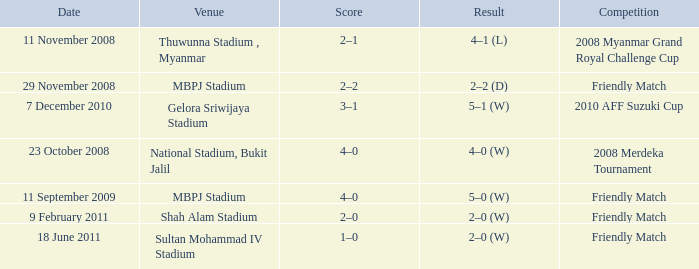Write the full table. {'header': ['Date', 'Venue', 'Score', 'Result', 'Competition'], 'rows': [['11 November 2008', 'Thuwunna Stadium , Myanmar', '2–1', '4–1 (L)', '2008 Myanmar Grand Royal Challenge Cup'], ['29 November 2008', 'MBPJ Stadium', '2–2', '2–2 (D)', 'Friendly Match'], ['7 December 2010', 'Gelora Sriwijaya Stadium', '3–1', '5–1 (W)', '2010 AFF Suzuki Cup'], ['23 October 2008', 'National Stadium, Bukit Jalil', '4–0', '4–0 (W)', '2008 Merdeka Tournament'], ['11 September 2009', 'MBPJ Stadium', '4–0', '5–0 (W)', 'Friendly Match'], ['9 February 2011', 'Shah Alam Stadium', '2–0', '2–0 (W)', 'Friendly Match'], ['18 June 2011', 'Sultan Mohammad IV Stadium', '1–0', '2–0 (W)', 'Friendly Match']]} What Competition in Shah Alam Stadium have a Result of 2–0 (w)? Friendly Match. 